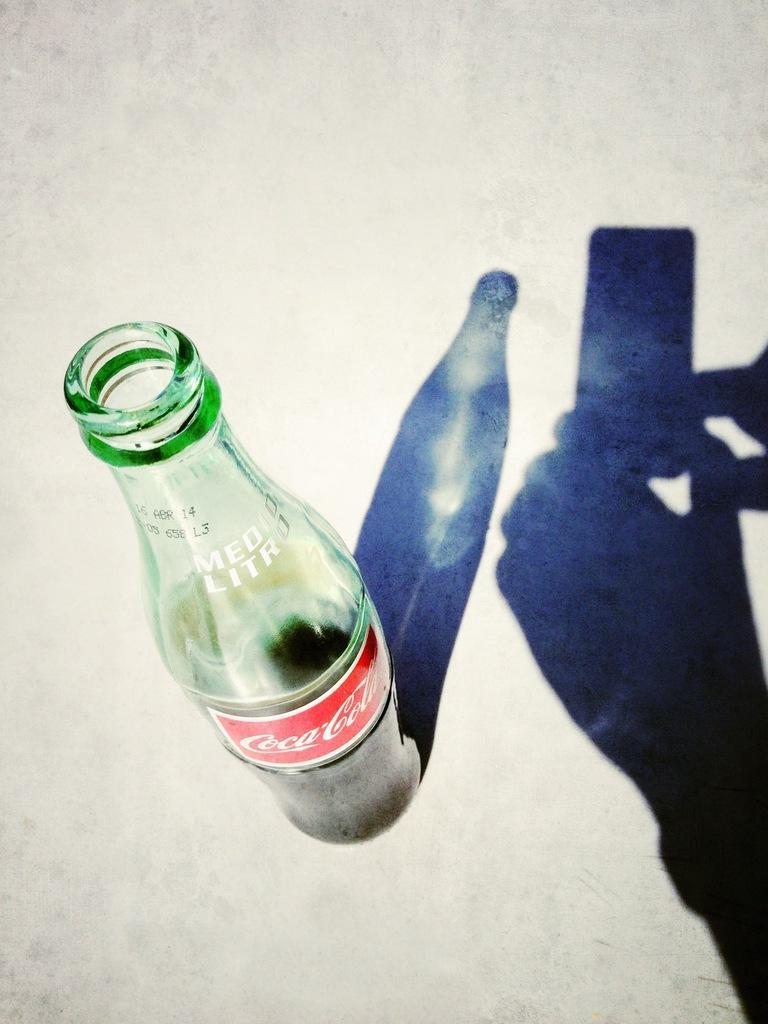How would you summarize this image in a sentence or two? Here we can see green color bottle and we can see shadow of the mobile hold with hands and bottle. 